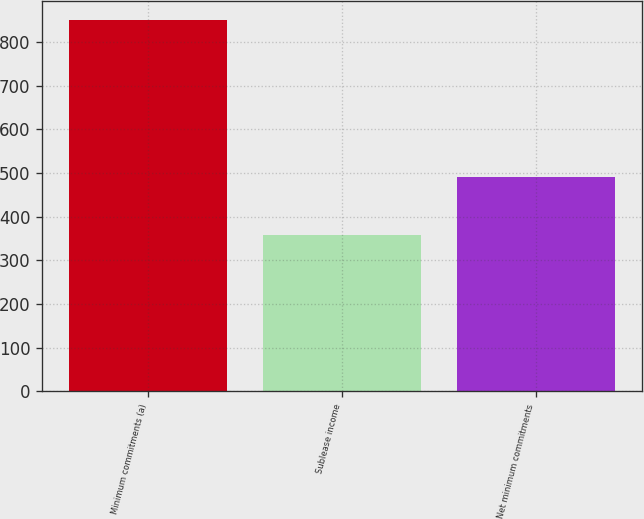Convert chart. <chart><loc_0><loc_0><loc_500><loc_500><bar_chart><fcel>Minimum commitments (a)<fcel>Sublease income<fcel>Net minimum commitments<nl><fcel>851<fcel>359<fcel>492<nl></chart> 